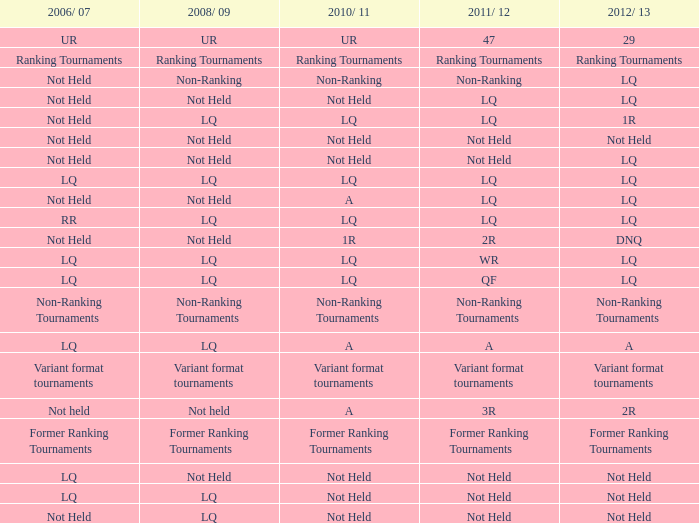What is 2006/07, if 2008/09 is lq, and if 2010/11 is not conducted? LQ, Not Held. 